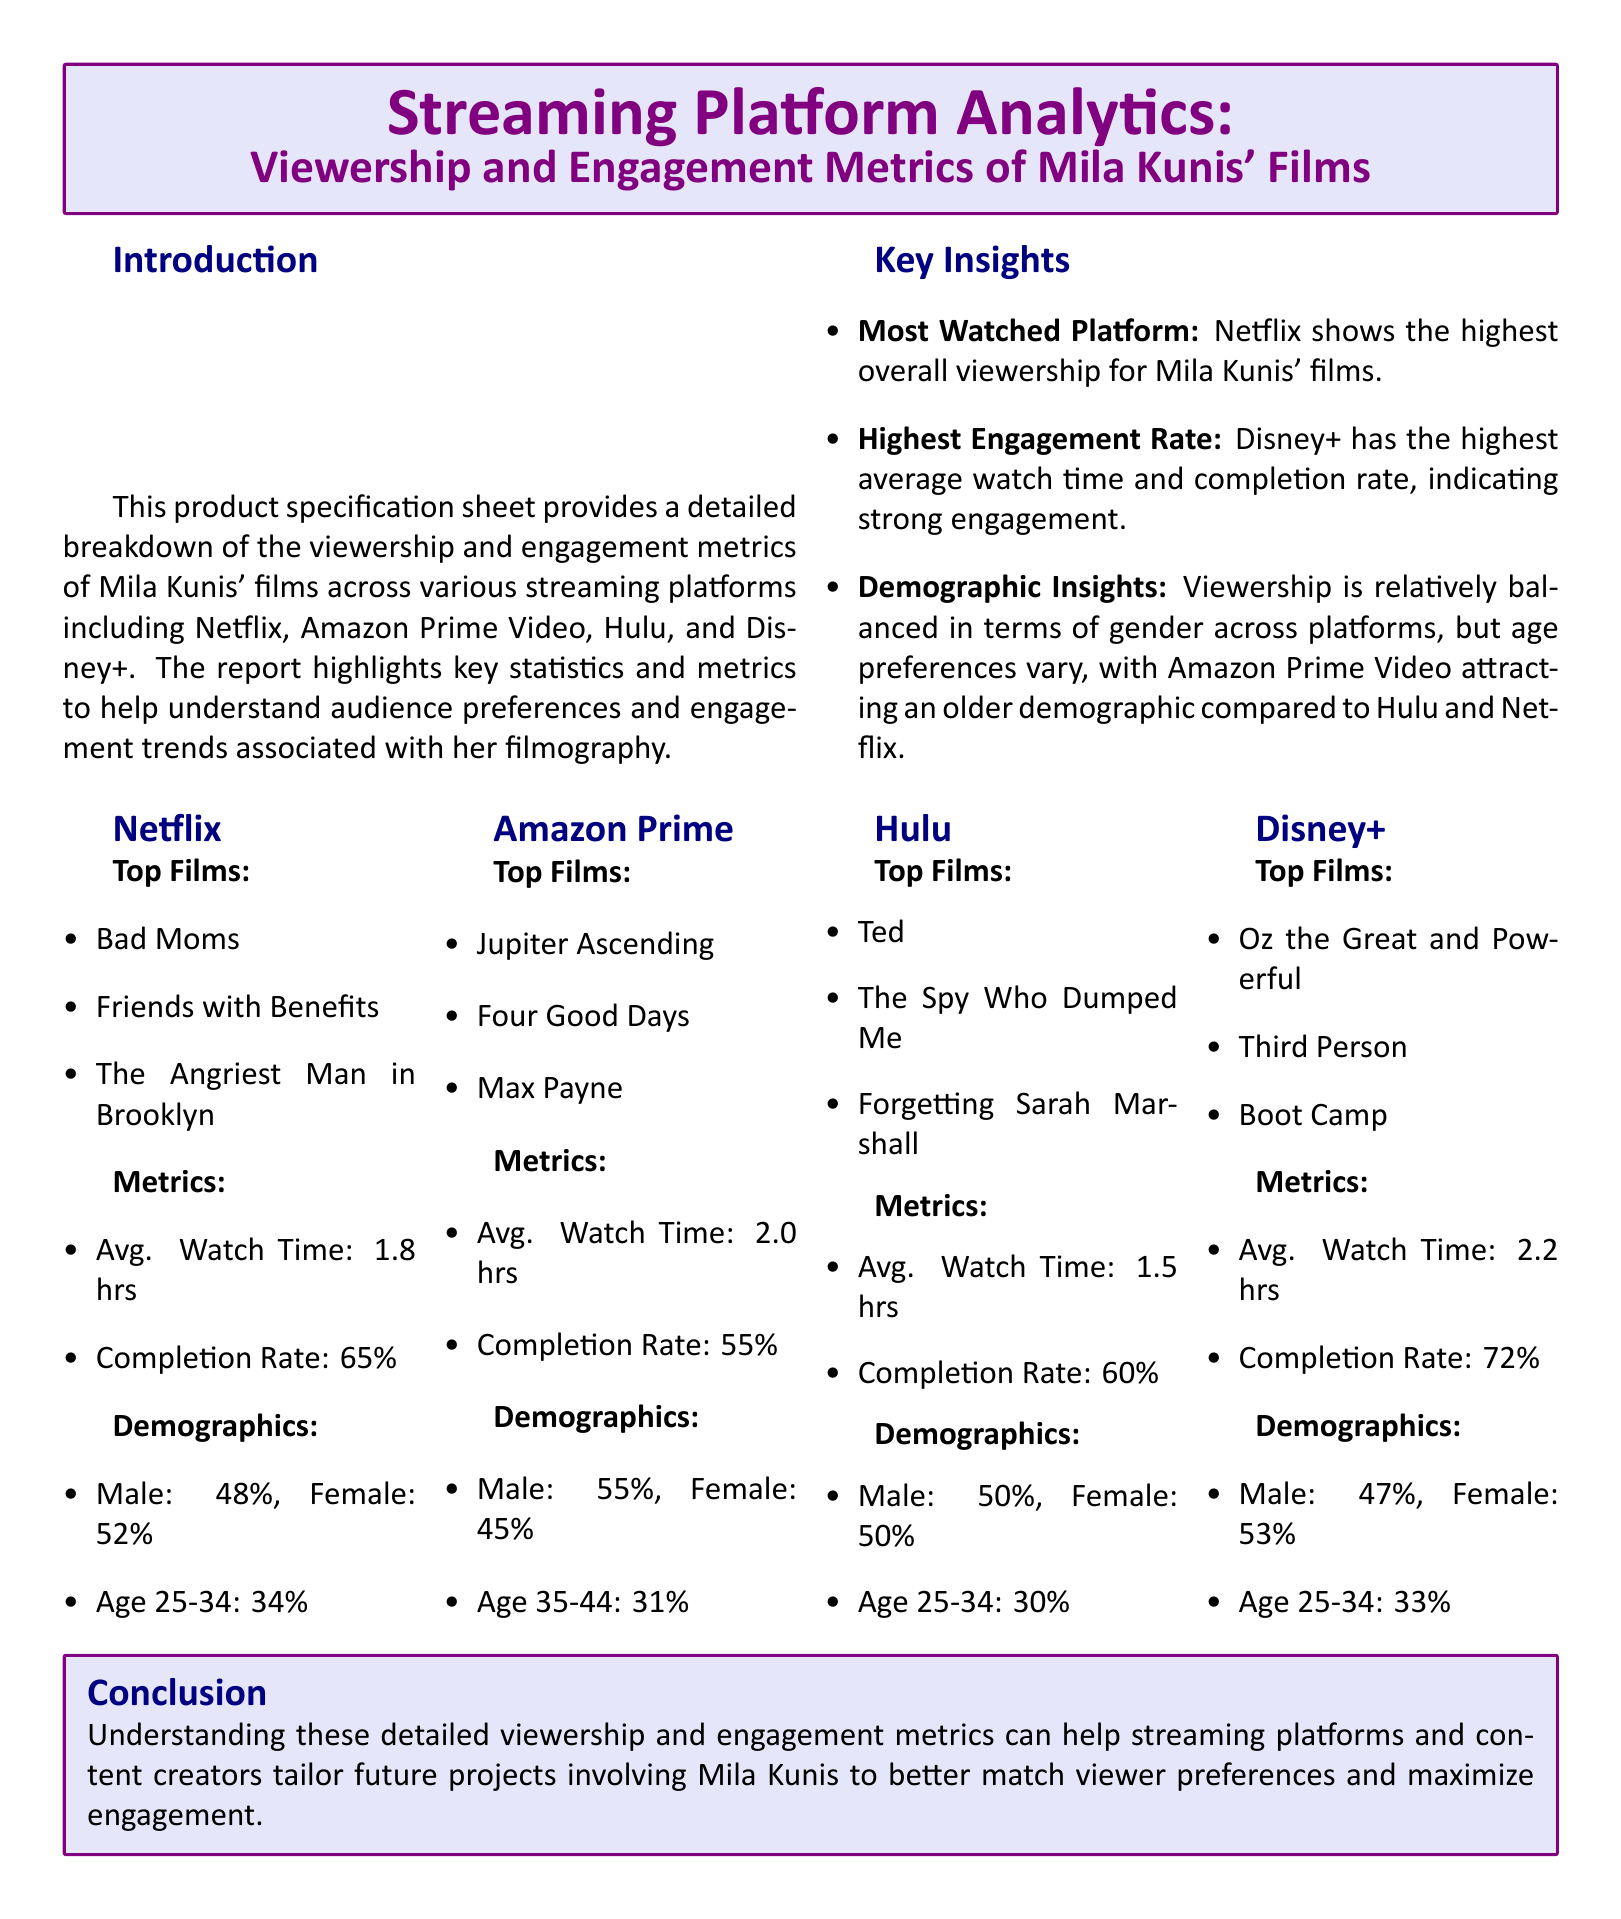What is the average watch time on Disney+? The document states the average watch time on Disney+ is 2.2 hours.
Answer: 2.2 hrs Which platform has the highest average watch time? According to the metrics, Disney+ has the highest average watch time among the platforms.
Answer: Disney+ What is the completion rate for Amazon Prime Video? The completion rate for Amazon Prime Video is provided in the metrics section, which is 55%.
Answer: 55% Which film is listed as a top film on Netflix? The document lists "Bad Moms" as a top film on Netflix.
Answer: Bad Moms What demographic percentage is Female on Hulu? The document indicates that the female demographic on Hulu is 50%.
Answer: 50% Which platform attracts an older demographic according to the report? The report states that Amazon Prime Video attracts an older demographic compared to other platforms.
Answer: Amazon Prime Video What is the completion rate for films on Disney+? The completion rate for films on Disney+ is specified to be 72%.
Answer: 72% What age range is most common for viewers on Netflix? The age range most common for viewers on Netflix is provided as 25-34 years old, making it the largest demographic.
Answer: Age 25-34 Which streaming platform has the highest engagement rate? According to the key insights, Disney+ has the highest engagement rate.
Answer: Disney+ 